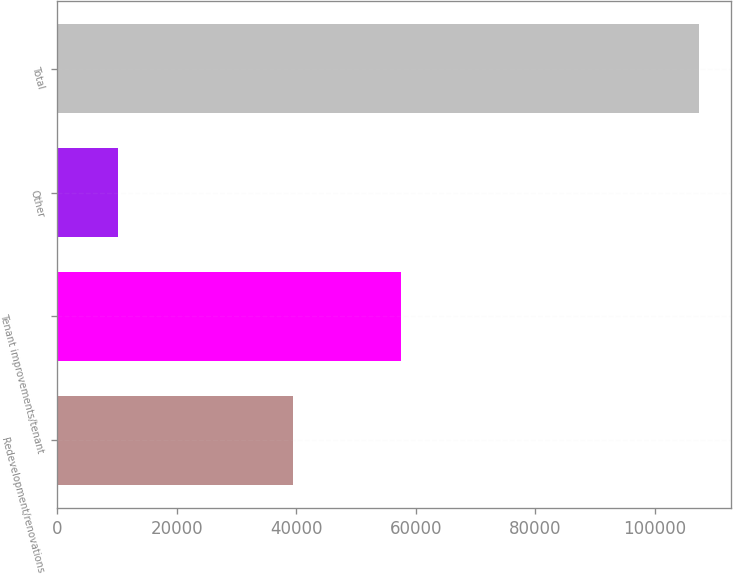Convert chart to OTSL. <chart><loc_0><loc_0><loc_500><loc_500><bar_chart><fcel>Redevelopment/renovations<fcel>Tenant improvements/tenant<fcel>Other<fcel>Total<nl><fcel>39531<fcel>57473<fcel>10273<fcel>107277<nl></chart> 